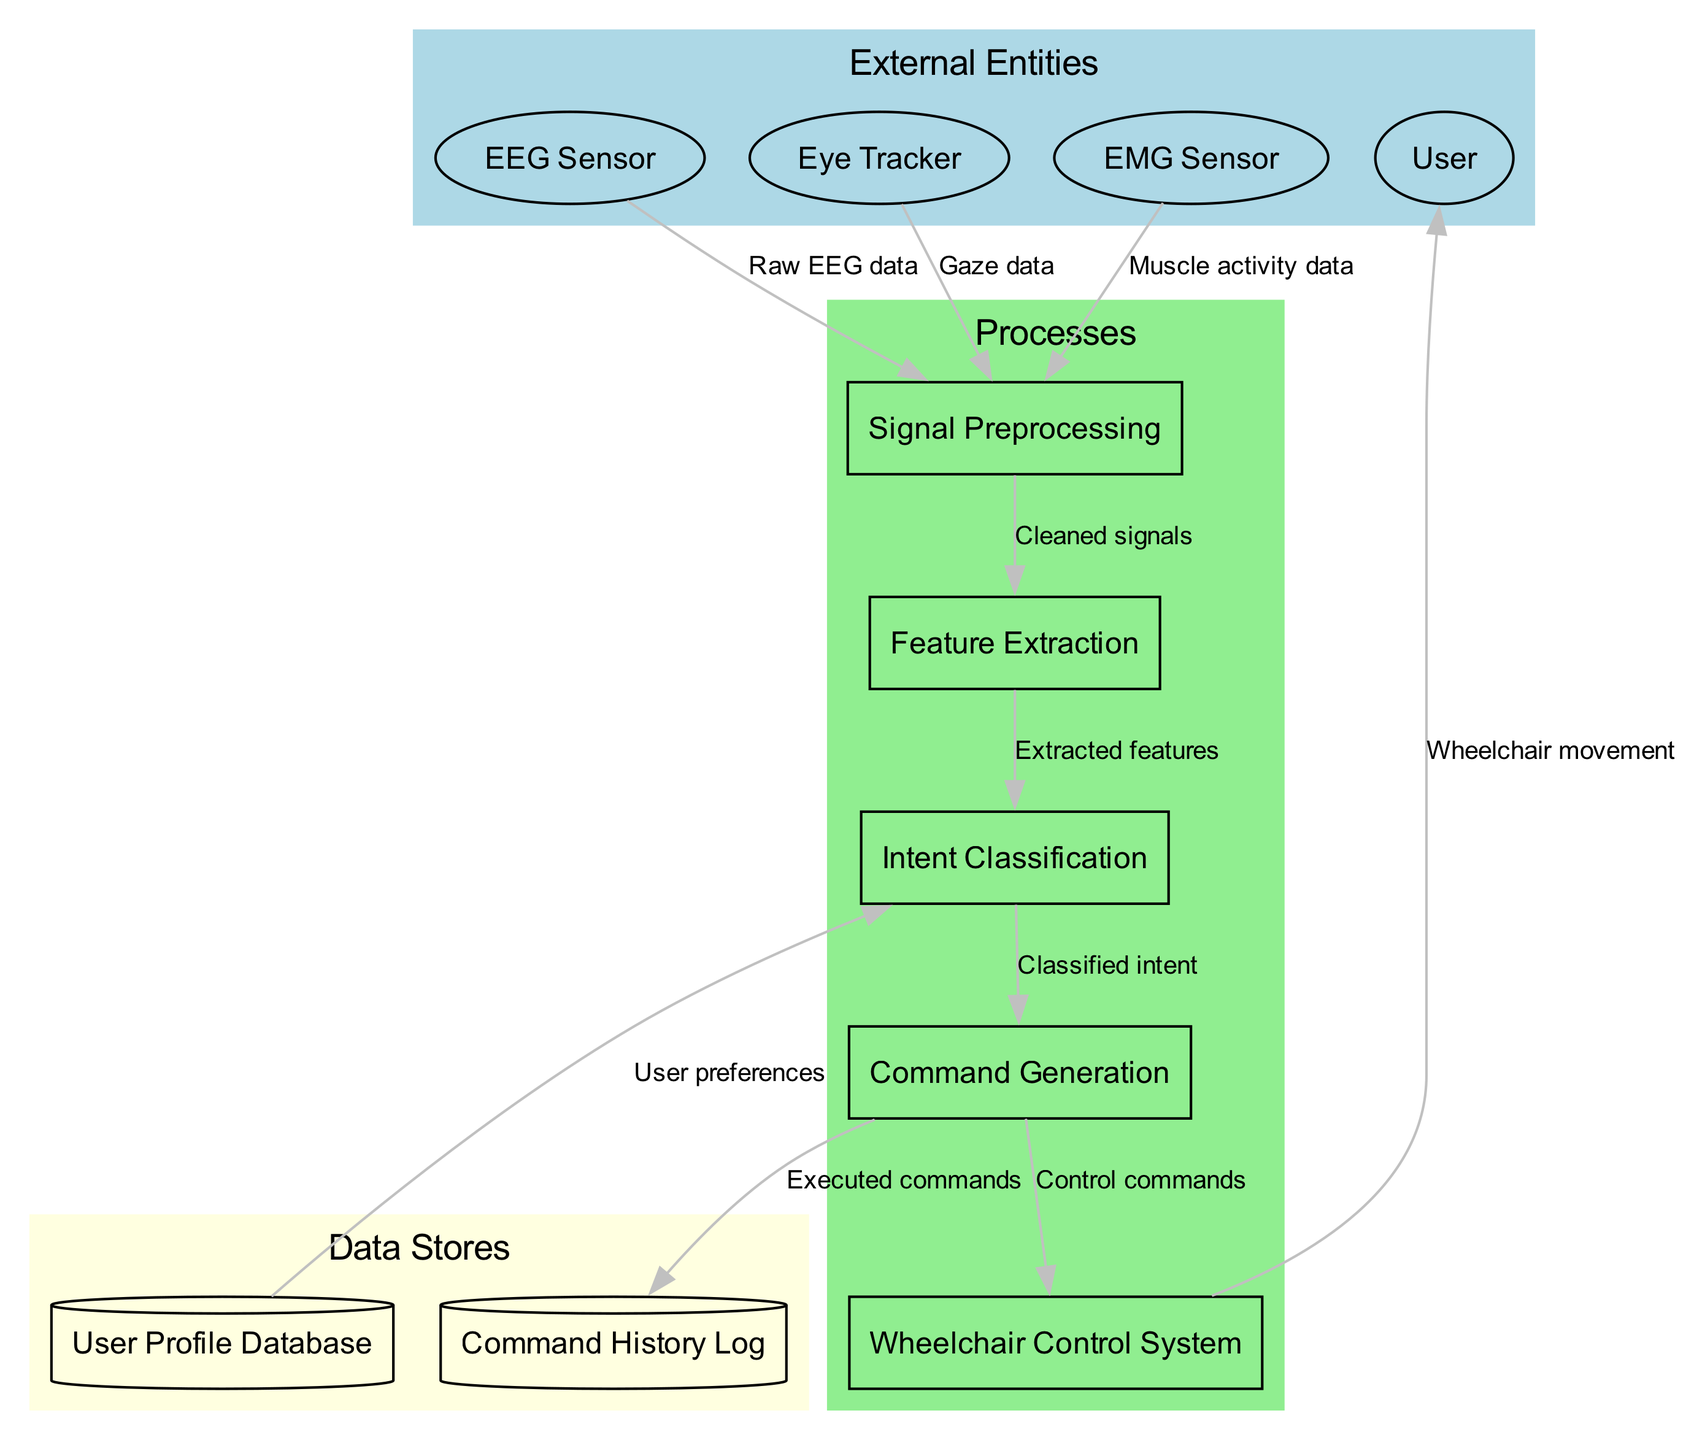What are the three external entities in the diagram? The external entities listed in the diagram are the EEG Sensor, Eye Tracker, and EMG Sensor. Each of these entities provides different types of raw data for the signal preprocessing process.
Answer: EEG Sensor, Eye Tracker, EMG Sensor How many data stores are present in the diagram? The diagram shows two data stores: the User Profile Database and the Command History Log. This counts the total number of data repositories utilized in the system.
Answer: 2 Which process receives gaze data as input? The Eye Tracker sends gaze data to the Signal Preprocessing step. This is the first point where the gaze data is utilized in the data flow.
Answer: Signal Preprocessing What data flow connects the Command Generation to the Wheelchair Control System? The data flow labeled "Control commands" connects the Command Generation process to the Wheelchair Control System, indicating that this is the command output for controlling the wheelchair.
Answer: Control commands Which process utilizes user preferences from a data store? The Intent Classification process utilizes user preferences obtained from the User Profile Database. This indicates the system is customized based on user-specific information.
Answer: Intent Classification What type of data flows from the Signal Preprocessing to the Feature Extraction? The flow from Signal Preprocessing to Feature Extraction is labeled "Cleaned signals." This label indicates that the signals have been preprocessed and are now in a refined state for feature extraction.
Answer: Cleaned signals How many processes are involved in the wheelchair control data flow? The diagram outlines five processes involved in the data flow for wheelchair control: Signal Preprocessing, Feature Extraction, Intent Classification, Command Generation, and Wheelchair Control System. This provides a comprehensive pathway for data processing.
Answer: 5 Which entity is considered the user of the system? The User is identified as the entity at the end of the data flow, receiving the output of the Wheelchair Control System, which indicates their role as the end-user of the system.
Answer: User What is the output of the Wheelchair Control System? The output from the Wheelchair Control System is labeled "Wheelchair movement," indicating the action taken based on the commands generated earlier in the processing flow.
Answer: Wheelchair movement 